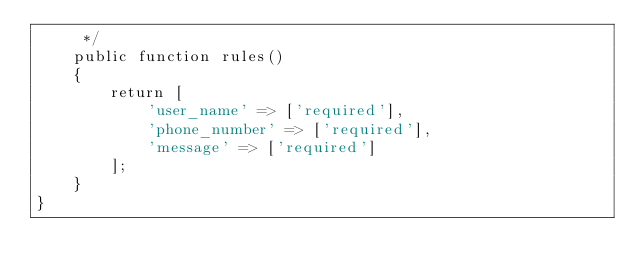<code> <loc_0><loc_0><loc_500><loc_500><_PHP_>     */
    public function rules()
    {
        return [
            'user_name' => ['required'],
            'phone_number' => ['required'],
            'message' => ['required']
        ];
    }
}
</code> 